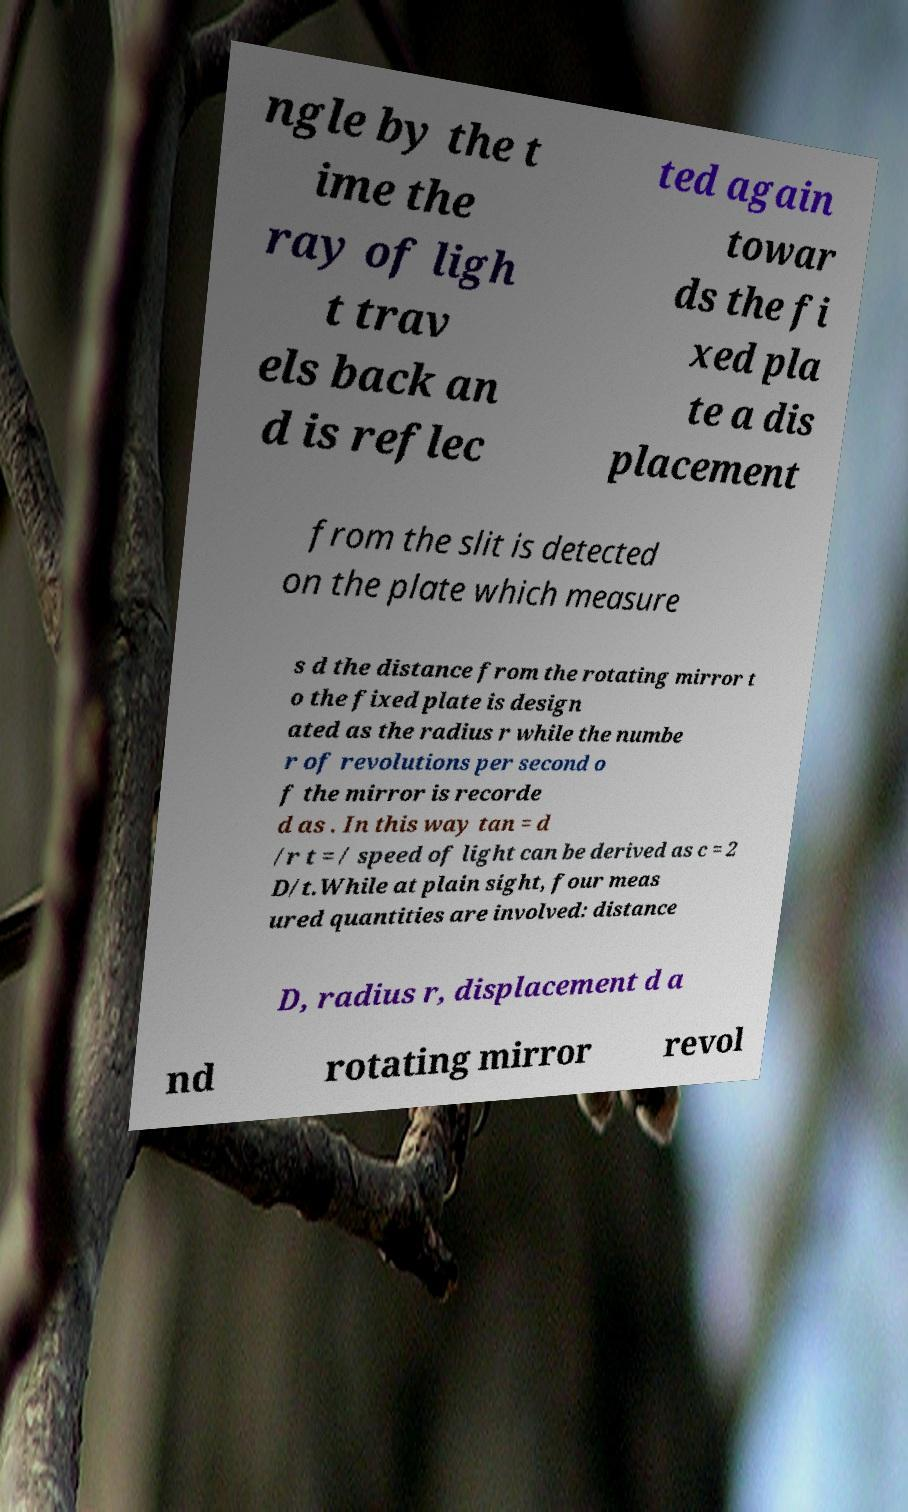Could you extract and type out the text from this image? ngle by the t ime the ray of ligh t trav els back an d is reflec ted again towar ds the fi xed pla te a dis placement from the slit is detected on the plate which measure s d the distance from the rotating mirror t o the fixed plate is design ated as the radius r while the numbe r of revolutions per second o f the mirror is recorde d as . In this way tan = d /r t = / speed of light can be derived as c = 2 D/t.While at plain sight, four meas ured quantities are involved: distance D, radius r, displacement d a nd rotating mirror revol 